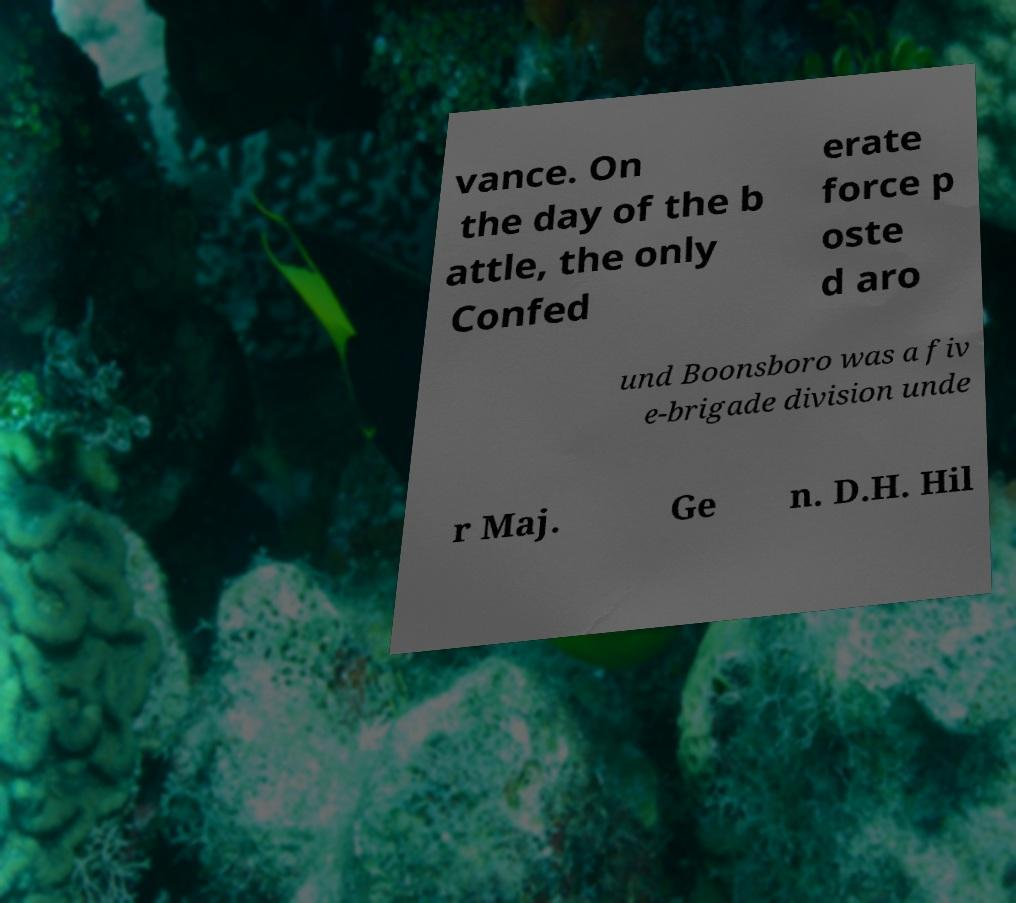What messages or text are displayed in this image? I need them in a readable, typed format. vance. On the day of the b attle, the only Confed erate force p oste d aro und Boonsboro was a fiv e-brigade division unde r Maj. Ge n. D.H. Hil 